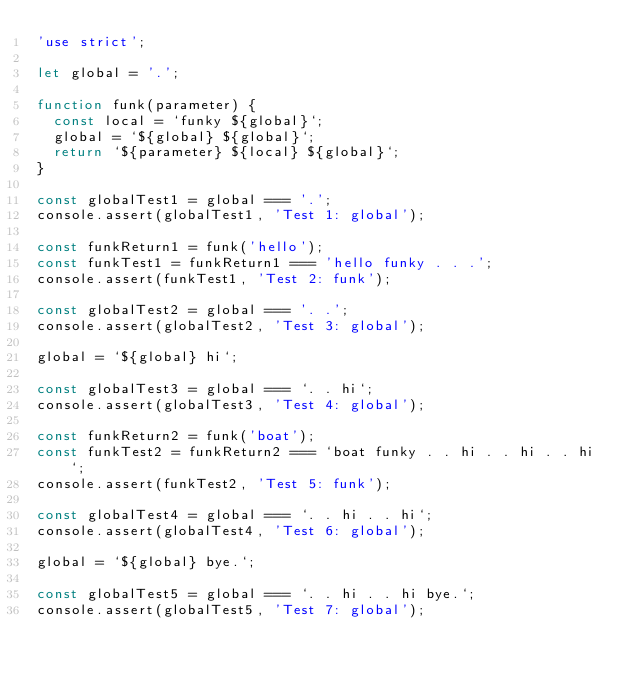<code> <loc_0><loc_0><loc_500><loc_500><_JavaScript_>'use strict';

let global = '.';

function funk(parameter) {
  const local = `funky ${global}`;
  global = `${global} ${global}`;
  return `${parameter} ${local} ${global}`;
}

const globalTest1 = global === '.';
console.assert(globalTest1, 'Test 1: global');

const funkReturn1 = funk('hello');
const funkTest1 = funkReturn1 === 'hello funky . . .';
console.assert(funkTest1, 'Test 2: funk');

const globalTest2 = global === '. .';
console.assert(globalTest2, 'Test 3: global');

global = `${global} hi`;

const globalTest3 = global === `. . hi`;
console.assert(globalTest3, 'Test 4: global');

const funkReturn2 = funk('boat');
const funkTest2 = funkReturn2 === `boat funky . . hi . . hi . . hi`;
console.assert(funkTest2, 'Test 5: funk');

const globalTest4 = global === `. . hi . . hi`;
console.assert(globalTest4, 'Test 6: global');

global = `${global} bye.`;

const globalTest5 = global === `. . hi . . hi bye.`;
console.assert(globalTest5, 'Test 7: global');
</code> 